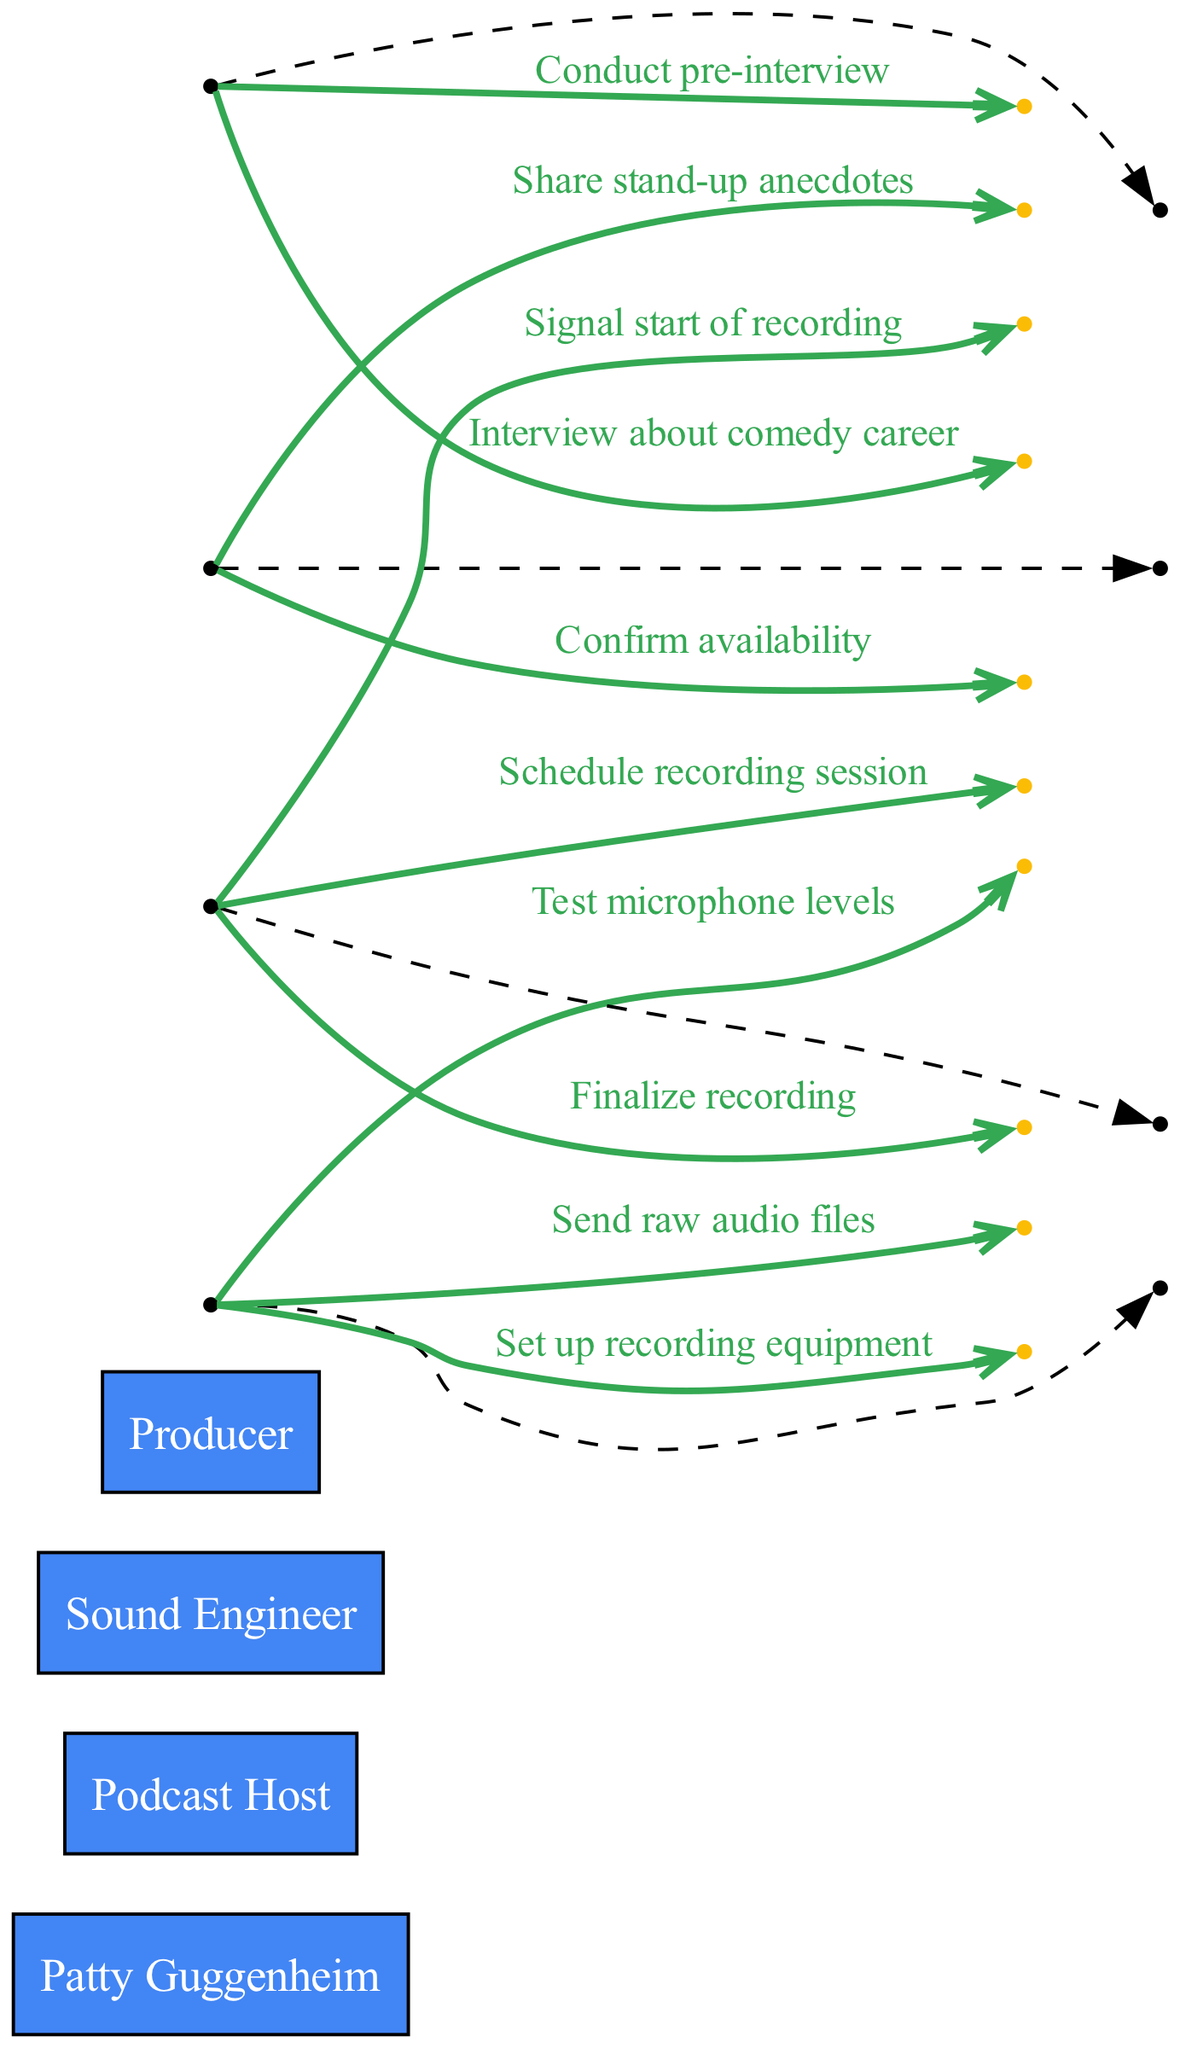What is the first action taken by the Producer? The first action taken by the Producer is to "Schedule recording session." This is directly noted as the first message in the sequence from the Producer to Patty Guggenheim.
Answer: Schedule recording session How many actors are involved in the podcast production? The diagram shows a total of four actors: Patty Guggenheim, Podcast Host, Sound Engineer, and Producer. This is evident through the list of actors defined at the beginning.
Answer: Four What does the Sound Engineer do after setting up the recording equipment? After "Set up recording equipment," the next action by the Sound Engineer is to "Test microphone levels." This can be traced by following the sequence from the Sound Engineer to Patty Guggenheim.
Answer: Test microphone levels Which actor conducts the interview with Patty Guggenheim? The Podcast Host conducts the interview with Patty Guggenheim. This is indicated by the message "Interview about comedy career," which comes from the Podcast Host directed to Patty Guggenheim.
Answer: Podcast Host What action follows Patty Guggenheim sharing stand-up anecdotes? After Patty Guggenheim shares stand-up anecdotes with the Podcast Host, the following action is "Finalize recording," which involves the Producer and the Sound Engineer. This can be confirmed by looking at the sequence steps.
Answer: Finalize recording Which message is sent by the Sound Engineer to the Producer last? The last message sent by the Sound Engineer to the Producer is "Send raw audio files." This is the final step in the sequence indicating the completion of the audio transfer.
Answer: Send raw audio files What is the relationship between the Podcast Host and Patty Guggenheim during the pre-interview? The relationship during the pre-interview is direct communication, as indicated by the message "Conduct pre-interview," which the Podcast Host sends to Patty Guggenheim.
Answer: Direct communication How many messages are exchanged between the Producer and Patty Guggenheim? There are two messages exchanged between the Producer and Patty Guggenheim: "Schedule recording session" and "Confirm availability." Counting these two messages gives the total.
Answer: Two 